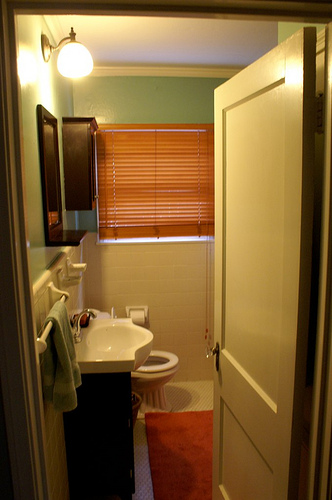Based on the image, what appliances are missing that would be typically found in a modern bathroom? A modern bathroom might typically include a few additional appliances that are missing in this image, such as a shower or bathtub, heated towel rack, modern vanity lighting, and perhaps an automatic hand dryer or a bidet attachment for the toilet. If the bathroom were designed for luxury, what elements would you expect to find? A luxurious bathroom would likely feature natural stone finishes like marble or granite, a spacious walk-in shower with high-end fixtures, possibly a soaking tub, heated floors, a double vanity with elegant sinks, smart mirrors with integrated lighting and defogging capabilities, and high-quality, plush towels and bathrobes. There might also be inbuilt speakers for a relaxing audio experience and ambient mood lighting. 